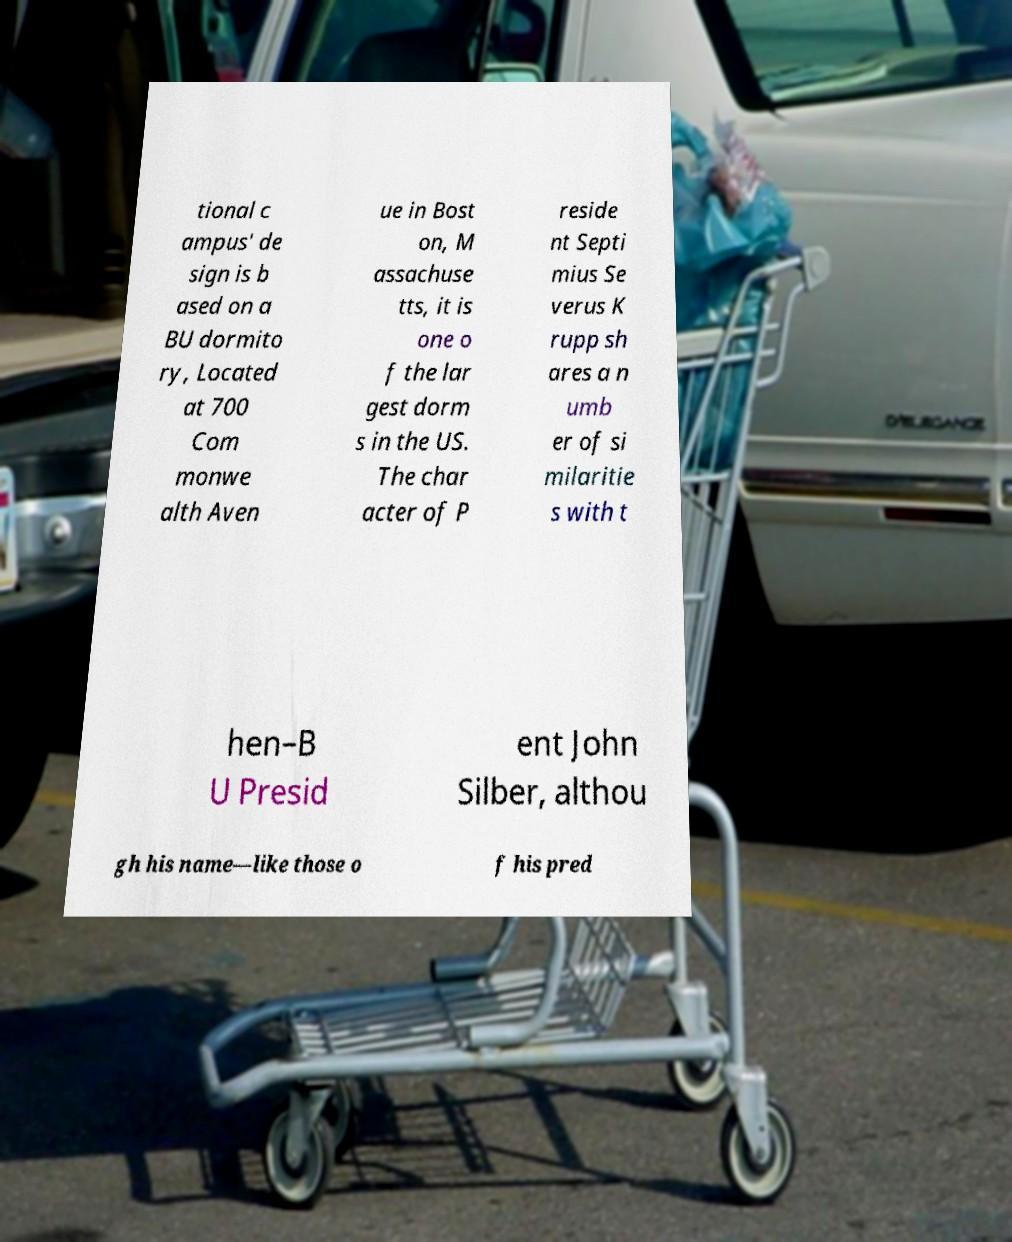There's text embedded in this image that I need extracted. Can you transcribe it verbatim? tional c ampus' de sign is b ased on a BU dormito ry, Located at 700 Com monwe alth Aven ue in Bost on, M assachuse tts, it is one o f the lar gest dorm s in the US. The char acter of P reside nt Septi mius Se verus K rupp sh ares a n umb er of si milaritie s with t hen–B U Presid ent John Silber, althou gh his name—like those o f his pred 